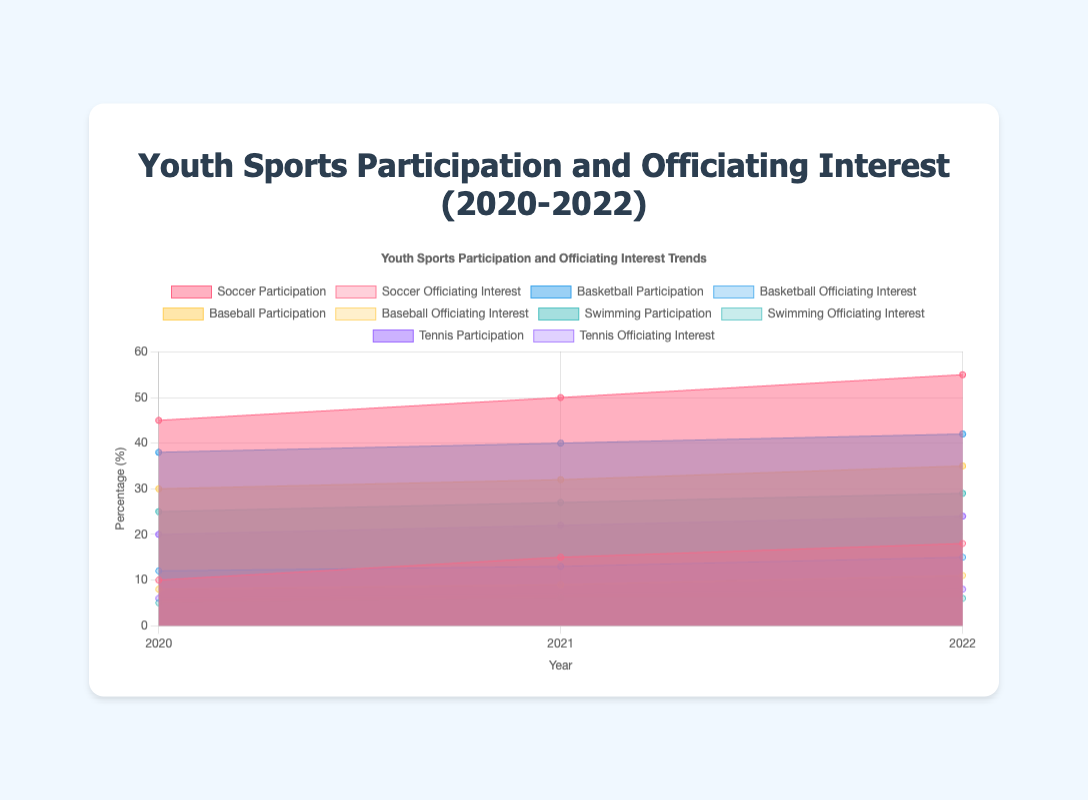What years are displayed on the x-axis? The x-axis shows the years, which are the labels indicating time progression horizontally. From the chart, we see the years 2020, 2021, and 2022.
Answer: 2020, 2021, 2022 Which sport had the highest participation rate in 2022? To determine this, we need to look at the participation rates across all sports for the year 2022. The highest value among them is for soccer, which is 55%.
Answer: Soccer Which sport had the lowest officiating interest in 2020? We check the officiating interests for all sports in 2020. Swimming had the lowest interest at 5%.
Answer: Swimming How did soccer participation change from 2020 to 2022? By checking the data for soccer participation in 2020 (45%) and 2022 (55%), we can see an increase. The difference is 55% - 45% = 10%.
Answer: It increased by 10% What is the average officiating interest for tennis over the three years? First, sum the officiating interest for tennis in each year: 6 (2020) + 7 (2021) + 8 (2022) = 21. Then, divide by the number of years (3). 21 / 3 = 7
Answer: 7 Which year had the highest overall officiating interest for baseball? We compare the officiating interest in baseball for each year: 8 (2020), 9 (2021), and 11 (2022). The highest value is 11 in 2022.
Answer: 2022 Between soccer and basketball, which sport had a greater increase in officiating interest from 2020 to 2022? Soccer had officiating interest increase from 10 to 18 (an increase of 8). Basketball increased from 12 to 15 (an increase of 3).
Answer: Soccer What was the participation rate for swimming in 2021? Look at the data for swimming participation in 2021, which is 27%.
Answer: 27% Which sport observed the largest increase in participation rate between 2020 and 2021? Calculate the change for each sport: Soccer (50-45=5), Basketball (40-38=2), Baseball (32-30=2), Swimming (27-25=2), Tennis (22-20=2). Soccer had the largest increase of 5%.
Answer: Soccer Is there a consistent trend in officiating interest for any sport from 2020 to 2022? Soccer, basketball, and baseball show consistent increases every year. Swimming remains constant between 2021 and 2022, while tennis steadily increases.
Answer: Soccer, Basketball, Baseball, Tennis 